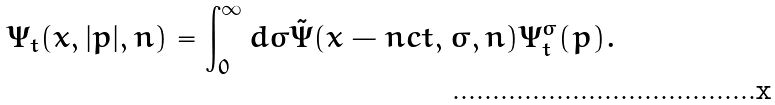Convert formula to latex. <formula><loc_0><loc_0><loc_500><loc_500>\Psi _ { t } ( { x } , | { p } | , { n } ) = \int _ { 0 } ^ { \infty } d \sigma \tilde { \Psi } ( { x } - { n } c t , \sigma , { n } ) \Psi _ { t } ^ { \sigma } ( { p } ) .</formula> 